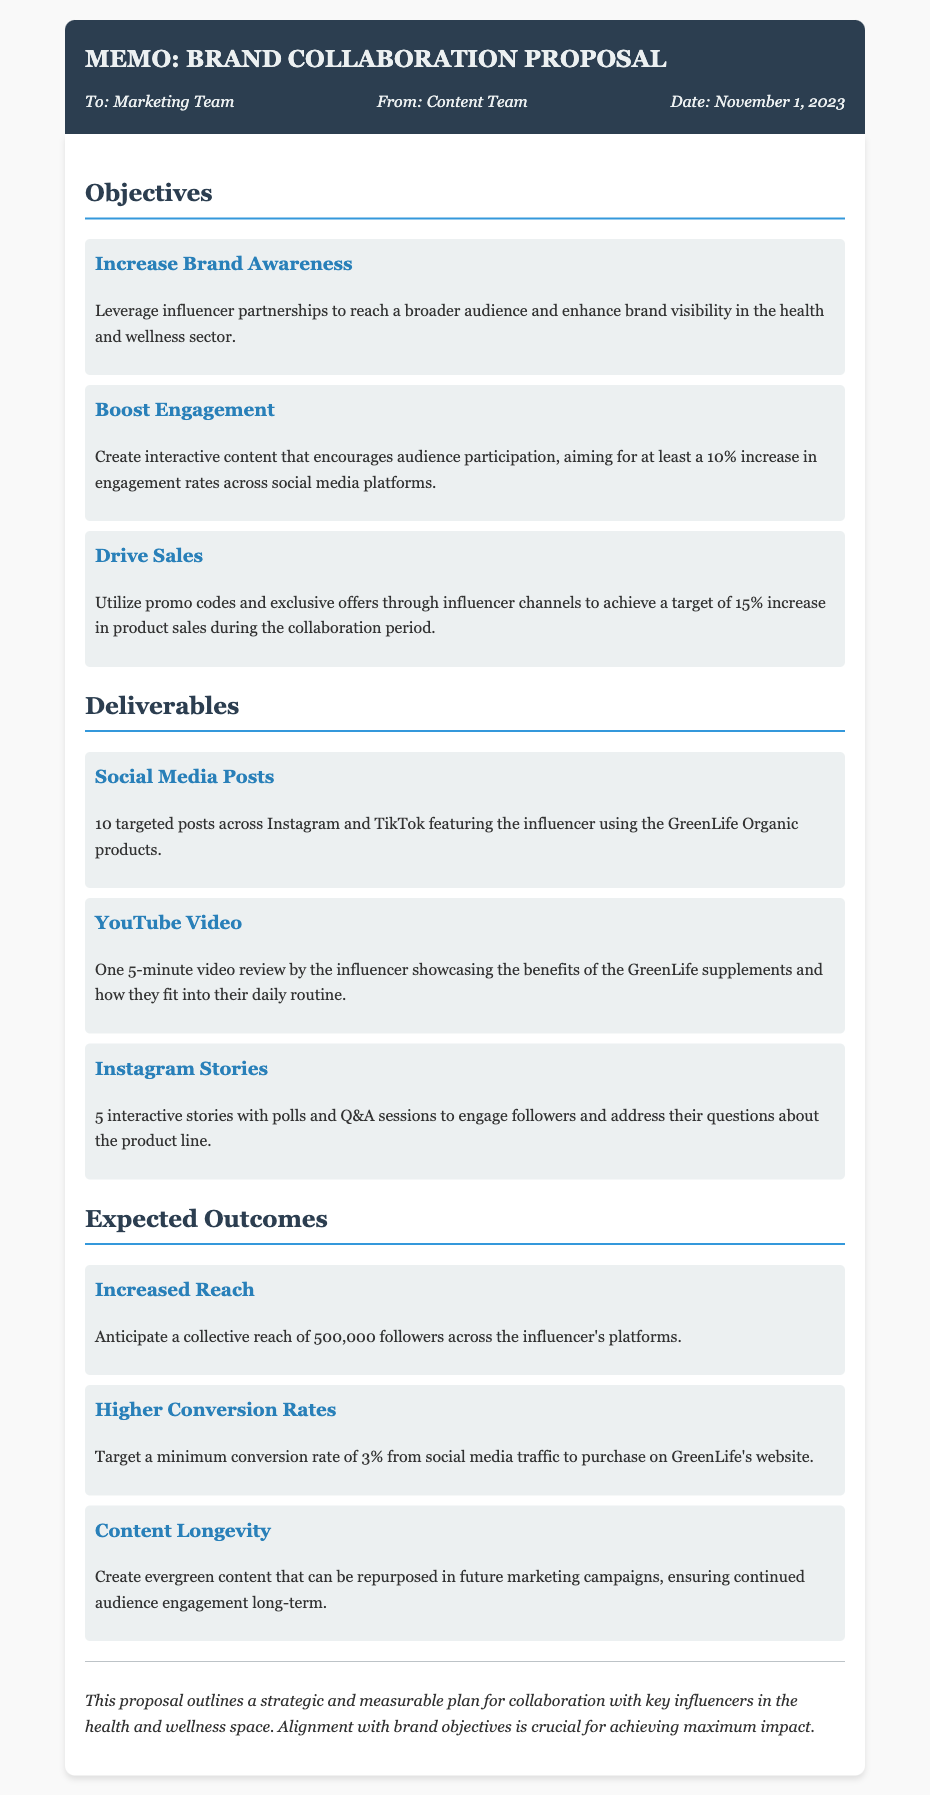What is the title of the memo? The title of the memo is found in the header section at the top of the document.
Answer: Brand Collaboration Proposal Who is the memo addressed to? The recipient of the memo is specified in the meta-info section under "To".
Answer: Marketing Team What is one objective mentioned in the proposal? Objectives are listed under a specific section, defining the goals of the collaboration.
Answer: Increase Brand Awareness How many social media posts are to be delivered? Deliverables are itemized, specifying the number of posts planned for social media.
Answer: 10 What is the expected collective reach across influencer platforms? The expected outcomes provide insights into anticipated performance metrics based on the collaboration's goals.
Answer: 500,000 followers What type of content is anticipated to ensure longevity? Outcomes describe the desired qualities of the content created through the collaboration.
Answer: Evergreen content What is the target minimum conversion rate mentioned? The expected outcomes section highlights quantifiable performance targets for the campaign.
Answer: 3% How many Instagram Stories are included in the deliverables? The deliverables section specifies the count of individual stories planned for the campaign.
Answer: 5 What is the date of the memo? The date is noted in the meta-info section, providing a clear reference for the document.
Answer: November 1, 2023 